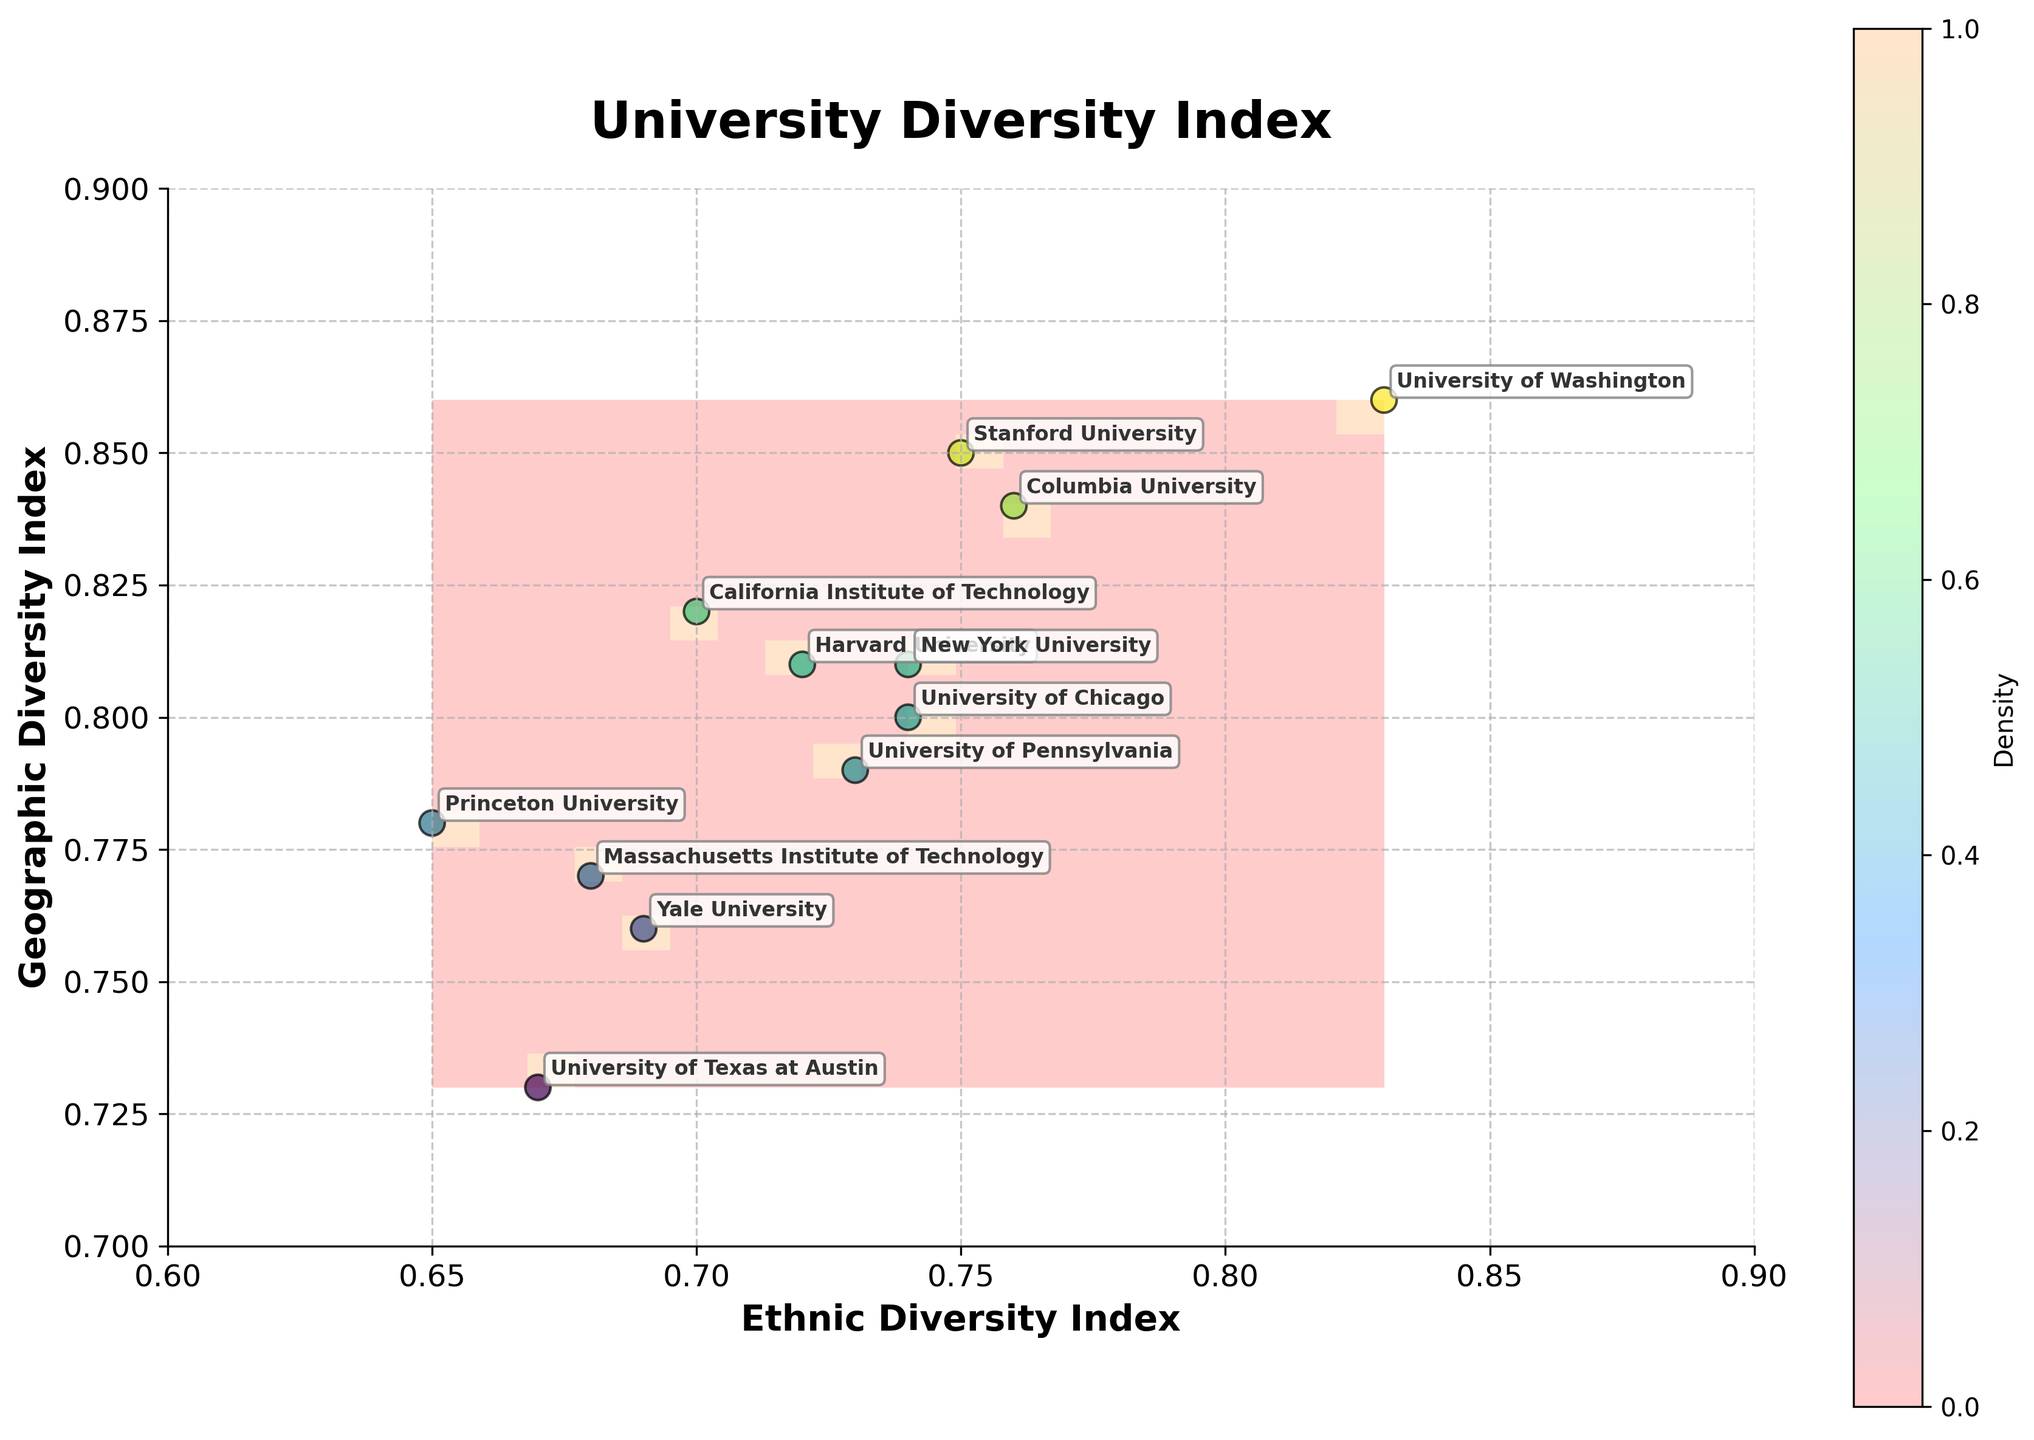what is the title of the plot? The title of the plot is usually found at the top center of the figure, providing an overview of the data being presented. In this case, it is associated with the diversity index across universities.
Answer: University Diversity Index What are the labels of the x and y axes? The axis labels are found along the x and y axes, specifying what each axis represents in the plot. Here, the x-axis label likely relates to ethnic diversity and the y-axis to geographic diversity.
Answer: Ethnic Diversity Index (x), Geographic Diversity Index (y) How many universities are plotted? To determine the number of universities, each university is represented by a scatter point in the plot. By counting these distinct labels, we can ascertain the total number. From the data, we see there are 12 universities.
Answer: 12 Which university has the highest ethnic diversity index? Look for the point on the x-axis (ethnic diversity) that is furthest to the right to find the university with the highest ethnic diversity. The maximum ethnic diversity index from the data is 0.83, belonging to the University of Washington.
Answer: University of Washington Which universities have both ethnic and geographic diversity indexes above 0.8? Locate the points that reside in the top right section of the plot where both axes' values surpass 0.8. These represent universities that exhibit high diversity in both categories.
Answer: Stanford, Columbia, University of Washington How does the ethnic diversity index of Massachusetts Institute of Technology compare to Yale University? Identify the scatter points labeled for these two universities and compare their positions on the x-axis. MIT (0.68) is slightly less ethnically diverse than Yale (0.69).
Answer: MIT has a lower ethnic diversity index than Yale What is the range of the geographic diversity index in the plot? The range is determined by identifying the minimum and maximum values on the y-axis. From the data, the minimum is 0.73 (University of Texas at Austin), and the maximum is 0.86 (University of Washington).
Answer: 0.73 to 0.86 Which university is geographically more diverse, Princeton University or Harvard University? Compare their positions on the y-axis (geographic diversity) and find their respective values. Princeton (0.78) is less diverse geographically than Harvard (0.81).
Answer: Harvard University What color represents the highest density region in the contour plot? Analyze the color gradient in the contour plot and identify the color corresponding to the highest density region, usually represented by the most intense or darkest color.
Answer: Darkest blue Which university appears closest to the point (0.74, 0.81) on the plot? Identify the data point on the plot closest to the coordinates (0.74, 0.81). From the scatter plot, New York University is situated approximately at these coordinates.
Answer: New York University 